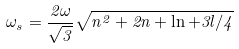Convert formula to latex. <formula><loc_0><loc_0><loc_500><loc_500>\omega _ { s } = \frac { 2 \omega } { \sqrt { 3 } } \sqrt { n ^ { 2 } + 2 n + \ln + 3 l / 4 }</formula> 